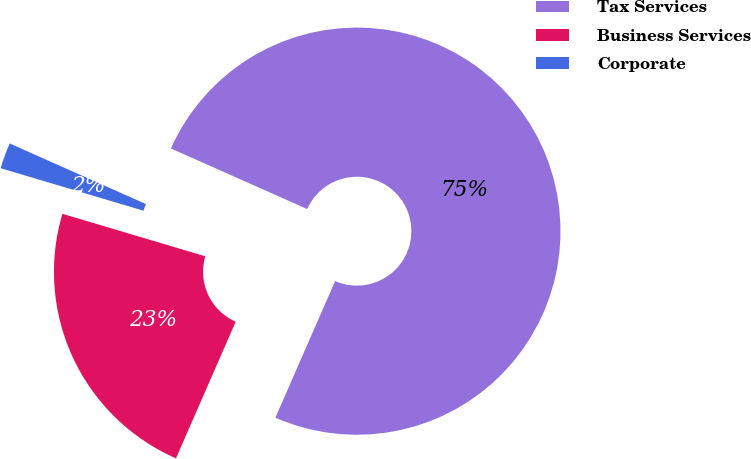Convert chart. <chart><loc_0><loc_0><loc_500><loc_500><pie_chart><fcel>Tax Services<fcel>Business Services<fcel>Corporate<nl><fcel>74.89%<fcel>23.04%<fcel>2.06%<nl></chart> 